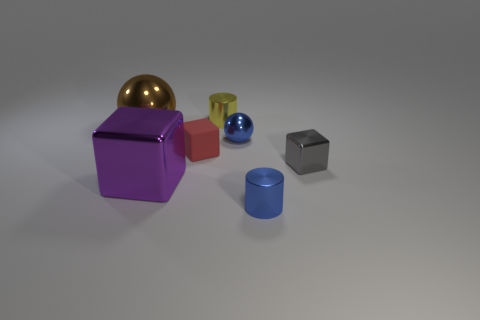Add 1 cylinders. How many objects exist? 8 Subtract all cylinders. How many objects are left? 5 Subtract all big purple rubber spheres. Subtract all small metallic objects. How many objects are left? 3 Add 7 blue cylinders. How many blue cylinders are left? 8 Add 4 purple metallic blocks. How many purple metallic blocks exist? 5 Subtract 0 purple cylinders. How many objects are left? 7 